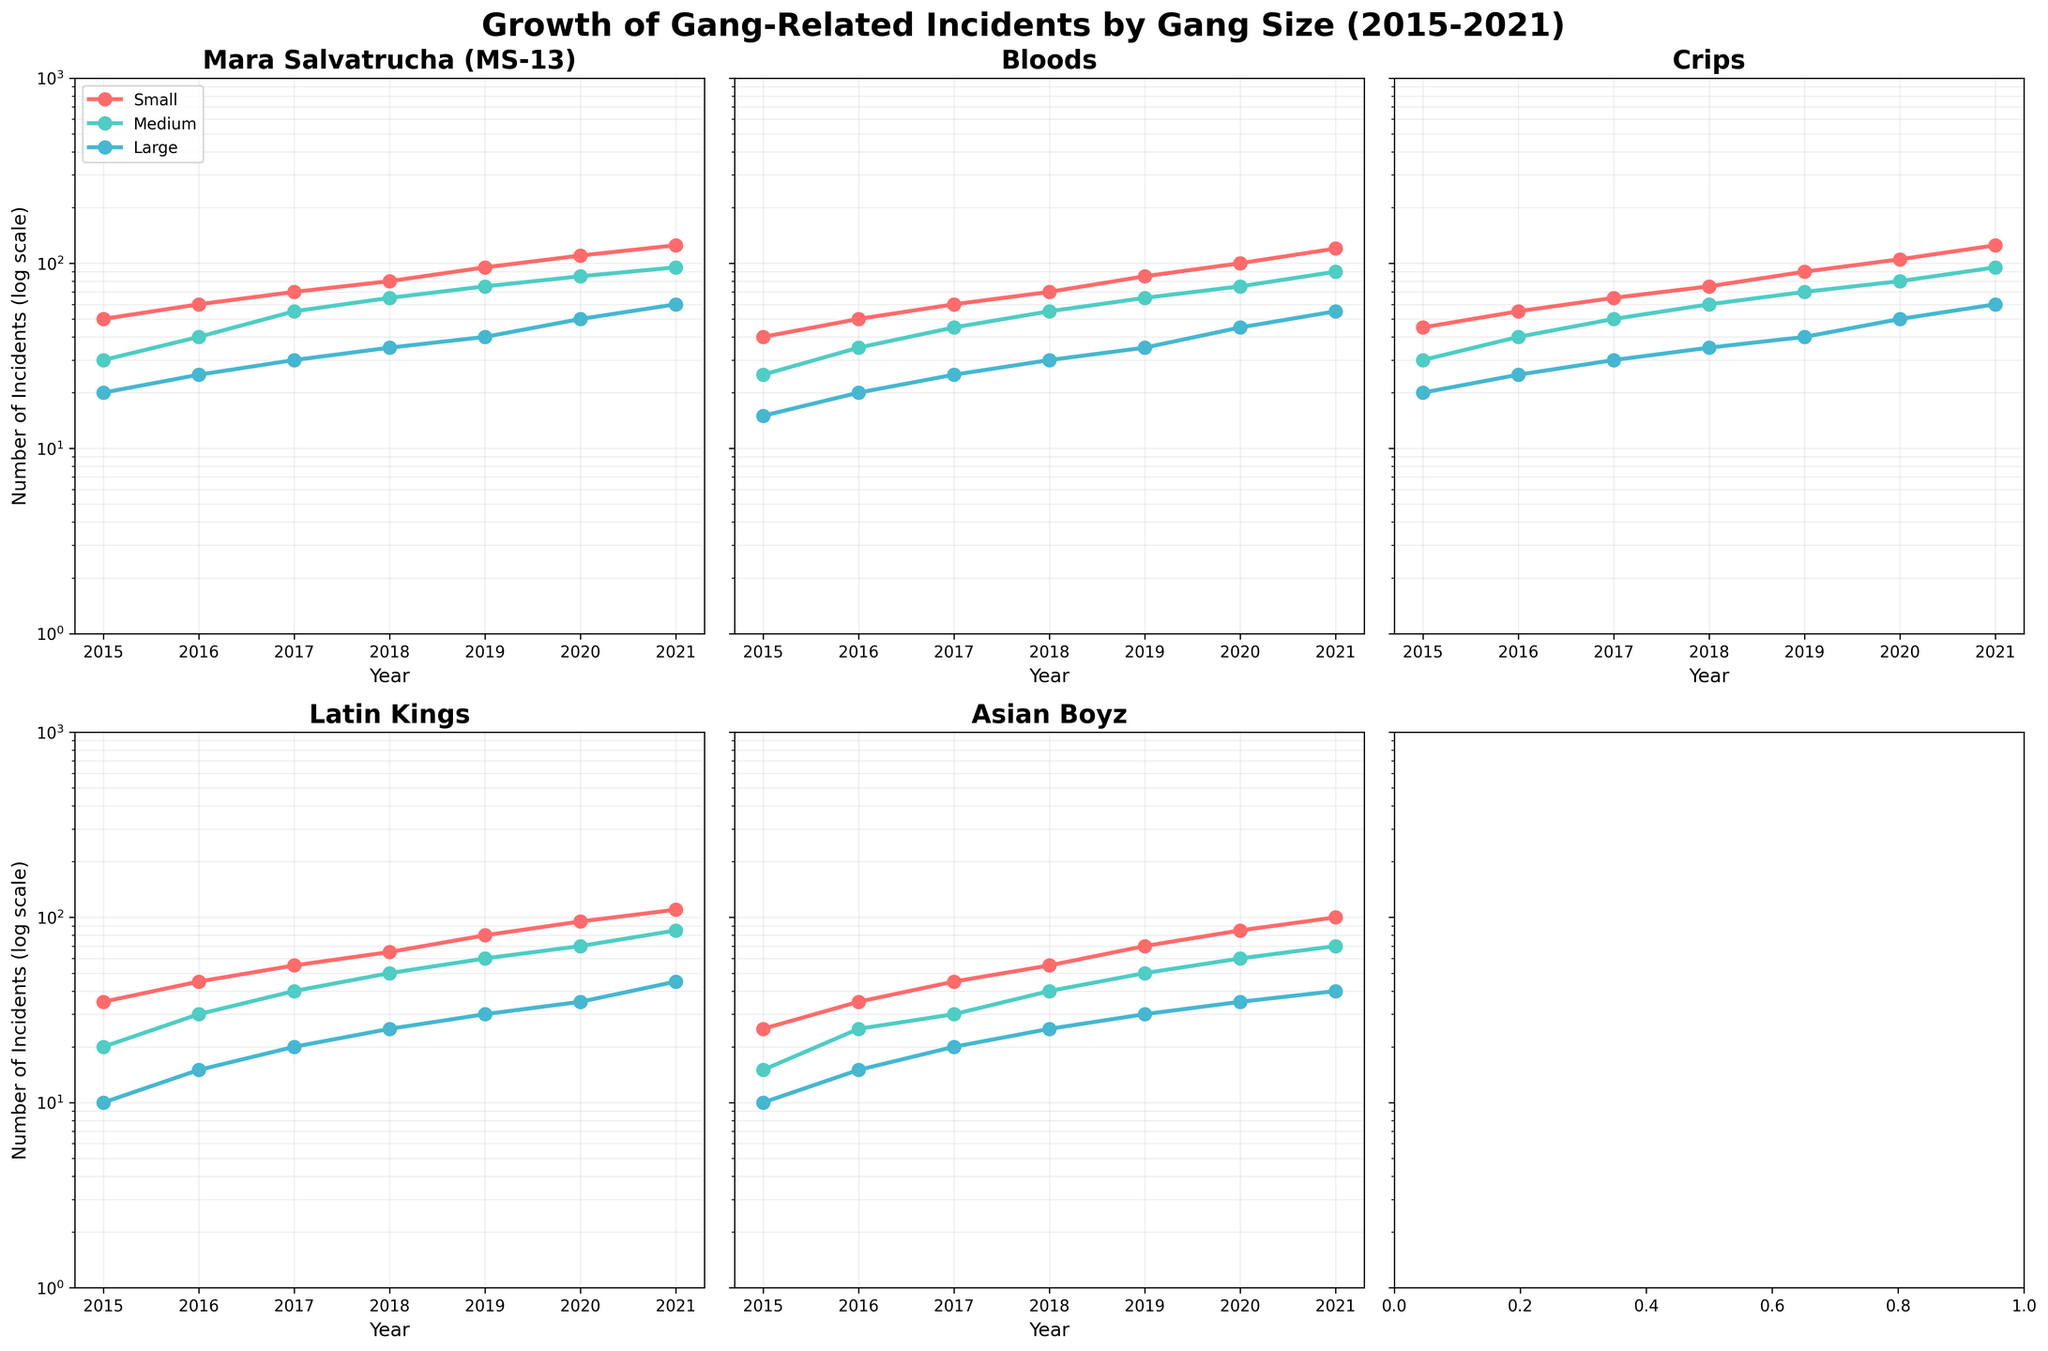Which gang has the highest number of small-sized incidents in 2021? To determine this, look at the 2021 data points for each gang under the 'Small' category. The highest value is 125 for Crips.
Answer: Crips How does the medium-sized incidents of the Bloods in 2016 compare to the Latin Kings in 2016? In 2016, medium-sized incidents for Bloods are 35, and for Latin Kings, 30. Since 35 is greater than 30, Bloods have more incidents.
Answer: Bloods have more incidents What is the difference in large-sized incidents reported by MS-13 between 2015 and 2021? The large-sized incidents for MS-13 in 2015 are 20, and in 2021 are 60. The difference is 60 - 20 = 40.
Answer: 40 Which year saw the smallest number of incidents for the Asian Boyz in all size categories? Look at the Asian Boyz data across all years. In 2015, they had 25 (Small), 15 (Medium), and 10 (Large), which are the smallest numbers in each category.
Answer: 2015 How does the growth trend in small-sized incidents for Latin Kings compare to that of Bloods from 2015 to 2021? Both gangs show an increasing trend in small-sized incidents from 2015 to 2021. Latin Kings start at 35 in 2015 and go up to 110, while Bloods start at 40 and go up to 120.
Answer: Both have increasing trends, Bloods start higher and end higher What is the average number of large-sized incidents of MS-13 over the years 2015 to 2021? Sum the large-sized incidents over the years: 20, 25, 30, 35, 40, 50, 60 -> Total is 260. Divide by 7 (number of years): 260/7 ≈ 37.14
Answer: 37.14 In which year did the Crips have more medium-sized incidents than Bloods and Latin Kings combined? Compare Crips' medium incidents with the sum of Bloods' and Latin Kings' values year by year. In 2016, Crips have 40 while Bloods and Latin Kings combined have 35 + 30 = 65, which doesn't fit. Repeat till 2019, Crips = 70, Bloods + Latin Kings = 65 + 60 = 125. In 2020, Crips have 80, Bloods + Latin Kings = 75 + 70 = 145. In 2021, Crips have 95, sum is 90 + 85 = 175. Thus, Crips never had more incidents than combined total in any year.
Answer: Never 